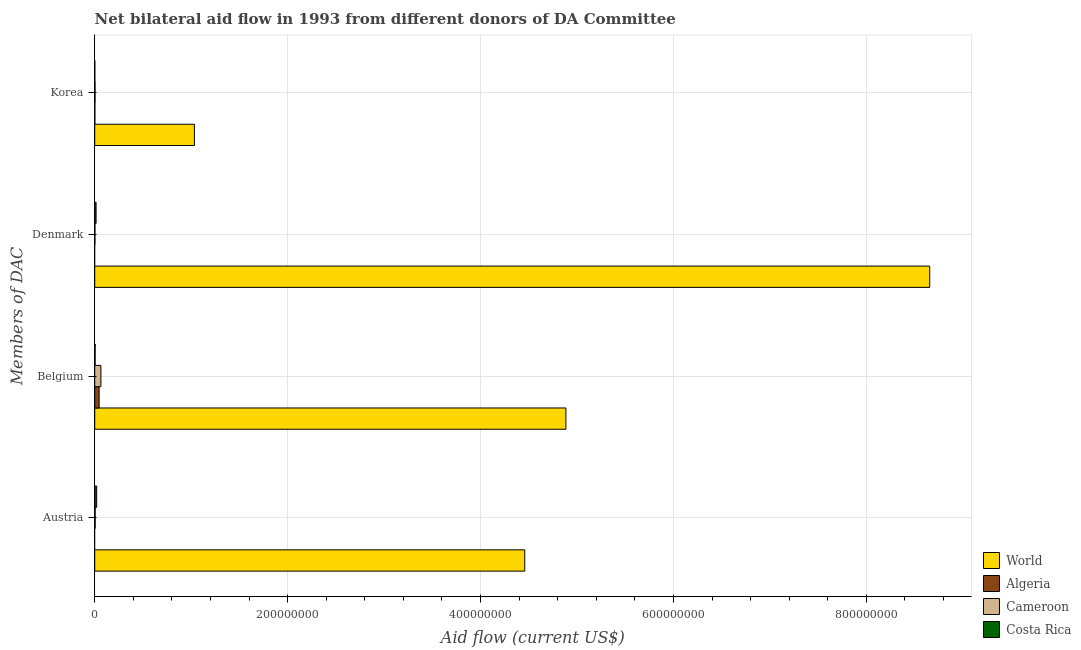How many different coloured bars are there?
Your response must be concise. 4. How many groups of bars are there?
Your answer should be compact. 4. Are the number of bars on each tick of the Y-axis equal?
Make the answer very short. No. How many bars are there on the 3rd tick from the top?
Your answer should be compact. 4. What is the label of the 3rd group of bars from the top?
Your response must be concise. Belgium. What is the amount of aid given by korea in Algeria?
Offer a very short reply. 1.10e+05. Across all countries, what is the maximum amount of aid given by korea?
Make the answer very short. 1.03e+08. In which country was the amount of aid given by austria maximum?
Make the answer very short. World. What is the total amount of aid given by denmark in the graph?
Offer a terse response. 8.67e+08. What is the difference between the amount of aid given by belgium in Algeria and that in Cameroon?
Ensure brevity in your answer.  -1.84e+06. What is the difference between the amount of aid given by belgium in Costa Rica and the amount of aid given by denmark in World?
Your answer should be very brief. -8.65e+08. What is the average amount of aid given by korea per country?
Your answer should be very brief. 2.60e+07. What is the difference between the amount of aid given by korea and amount of aid given by austria in World?
Your answer should be very brief. -3.43e+08. What is the ratio of the amount of aid given by belgium in Cameroon to that in Algeria?
Your answer should be compact. 1.4. Is the difference between the amount of aid given by austria in Cameroon and Costa Rica greater than the difference between the amount of aid given by denmark in Cameroon and Costa Rica?
Provide a succinct answer. No. What is the difference between the highest and the second highest amount of aid given by austria?
Ensure brevity in your answer.  4.44e+08. What is the difference between the highest and the lowest amount of aid given by belgium?
Your answer should be very brief. 4.88e+08. Is the sum of the amount of aid given by austria in Cameroon and World greater than the maximum amount of aid given by korea across all countries?
Offer a very short reply. Yes. Is it the case that in every country, the sum of the amount of aid given by austria and amount of aid given by belgium is greater than the amount of aid given by denmark?
Keep it short and to the point. Yes. How many bars are there?
Your response must be concise. 14. Are all the bars in the graph horizontal?
Keep it short and to the point. Yes. How many countries are there in the graph?
Offer a very short reply. 4. Does the graph contain any zero values?
Provide a short and direct response. Yes. Does the graph contain grids?
Your answer should be compact. Yes. Where does the legend appear in the graph?
Provide a succinct answer. Bottom right. How many legend labels are there?
Your response must be concise. 4. What is the title of the graph?
Your answer should be very brief. Net bilateral aid flow in 1993 from different donors of DA Committee. Does "Kyrgyz Republic" appear as one of the legend labels in the graph?
Your response must be concise. No. What is the label or title of the X-axis?
Your answer should be very brief. Aid flow (current US$). What is the label or title of the Y-axis?
Your answer should be very brief. Members of DAC. What is the Aid flow (current US$) of World in Austria?
Offer a terse response. 4.46e+08. What is the Aid flow (current US$) of Cameroon in Austria?
Your answer should be compact. 4.60e+05. What is the Aid flow (current US$) of Costa Rica in Austria?
Offer a very short reply. 2.01e+06. What is the Aid flow (current US$) of World in Belgium?
Give a very brief answer. 4.88e+08. What is the Aid flow (current US$) in Algeria in Belgium?
Ensure brevity in your answer.  4.55e+06. What is the Aid flow (current US$) in Cameroon in Belgium?
Give a very brief answer. 6.39e+06. What is the Aid flow (current US$) of World in Denmark?
Give a very brief answer. 8.66e+08. What is the Aid flow (current US$) of Algeria in Denmark?
Offer a very short reply. 0. What is the Aid flow (current US$) in Costa Rica in Denmark?
Provide a short and direct response. 1.40e+06. What is the Aid flow (current US$) in World in Korea?
Make the answer very short. 1.03e+08. What is the Aid flow (current US$) of Algeria in Korea?
Make the answer very short. 1.10e+05. What is the Aid flow (current US$) of Cameroon in Korea?
Offer a terse response. 3.30e+05. What is the Aid flow (current US$) in Costa Rica in Korea?
Your response must be concise. 1.00e+05. Across all Members of DAC, what is the maximum Aid flow (current US$) of World?
Give a very brief answer. 8.66e+08. Across all Members of DAC, what is the maximum Aid flow (current US$) of Algeria?
Your answer should be compact. 4.55e+06. Across all Members of DAC, what is the maximum Aid flow (current US$) in Cameroon?
Keep it short and to the point. 6.39e+06. Across all Members of DAC, what is the maximum Aid flow (current US$) in Costa Rica?
Offer a very short reply. 2.01e+06. Across all Members of DAC, what is the minimum Aid flow (current US$) of World?
Give a very brief answer. 1.03e+08. Across all Members of DAC, what is the minimum Aid flow (current US$) of Cameroon?
Your answer should be very brief. 2.20e+05. What is the total Aid flow (current US$) of World in the graph?
Make the answer very short. 1.90e+09. What is the total Aid flow (current US$) of Algeria in the graph?
Offer a terse response. 4.66e+06. What is the total Aid flow (current US$) of Cameroon in the graph?
Offer a very short reply. 7.40e+06. What is the total Aid flow (current US$) in Costa Rica in the graph?
Provide a short and direct response. 3.91e+06. What is the difference between the Aid flow (current US$) of World in Austria and that in Belgium?
Provide a short and direct response. -4.26e+07. What is the difference between the Aid flow (current US$) in Cameroon in Austria and that in Belgium?
Your response must be concise. -5.93e+06. What is the difference between the Aid flow (current US$) of Costa Rica in Austria and that in Belgium?
Offer a terse response. 1.61e+06. What is the difference between the Aid flow (current US$) of World in Austria and that in Denmark?
Your answer should be very brief. -4.20e+08. What is the difference between the Aid flow (current US$) of Costa Rica in Austria and that in Denmark?
Provide a short and direct response. 6.10e+05. What is the difference between the Aid flow (current US$) of World in Austria and that in Korea?
Provide a short and direct response. 3.43e+08. What is the difference between the Aid flow (current US$) of Costa Rica in Austria and that in Korea?
Your answer should be very brief. 1.91e+06. What is the difference between the Aid flow (current US$) of World in Belgium and that in Denmark?
Your response must be concise. -3.77e+08. What is the difference between the Aid flow (current US$) in Cameroon in Belgium and that in Denmark?
Make the answer very short. 6.17e+06. What is the difference between the Aid flow (current US$) of Costa Rica in Belgium and that in Denmark?
Your answer should be very brief. -1.00e+06. What is the difference between the Aid flow (current US$) in World in Belgium and that in Korea?
Give a very brief answer. 3.85e+08. What is the difference between the Aid flow (current US$) in Algeria in Belgium and that in Korea?
Your answer should be very brief. 4.44e+06. What is the difference between the Aid flow (current US$) of Cameroon in Belgium and that in Korea?
Keep it short and to the point. 6.06e+06. What is the difference between the Aid flow (current US$) of World in Denmark and that in Korea?
Your response must be concise. 7.62e+08. What is the difference between the Aid flow (current US$) of Cameroon in Denmark and that in Korea?
Offer a terse response. -1.10e+05. What is the difference between the Aid flow (current US$) in Costa Rica in Denmark and that in Korea?
Offer a very short reply. 1.30e+06. What is the difference between the Aid flow (current US$) in World in Austria and the Aid flow (current US$) in Algeria in Belgium?
Your response must be concise. 4.41e+08. What is the difference between the Aid flow (current US$) of World in Austria and the Aid flow (current US$) of Cameroon in Belgium?
Provide a short and direct response. 4.39e+08. What is the difference between the Aid flow (current US$) in World in Austria and the Aid flow (current US$) in Costa Rica in Belgium?
Your answer should be compact. 4.45e+08. What is the difference between the Aid flow (current US$) of Cameroon in Austria and the Aid flow (current US$) of Costa Rica in Belgium?
Offer a very short reply. 6.00e+04. What is the difference between the Aid flow (current US$) in World in Austria and the Aid flow (current US$) in Cameroon in Denmark?
Provide a succinct answer. 4.46e+08. What is the difference between the Aid flow (current US$) of World in Austria and the Aid flow (current US$) of Costa Rica in Denmark?
Your answer should be very brief. 4.44e+08. What is the difference between the Aid flow (current US$) of Cameroon in Austria and the Aid flow (current US$) of Costa Rica in Denmark?
Your answer should be compact. -9.40e+05. What is the difference between the Aid flow (current US$) in World in Austria and the Aid flow (current US$) in Algeria in Korea?
Offer a very short reply. 4.46e+08. What is the difference between the Aid flow (current US$) in World in Austria and the Aid flow (current US$) in Cameroon in Korea?
Provide a short and direct response. 4.46e+08. What is the difference between the Aid flow (current US$) of World in Austria and the Aid flow (current US$) of Costa Rica in Korea?
Provide a succinct answer. 4.46e+08. What is the difference between the Aid flow (current US$) in World in Belgium and the Aid flow (current US$) in Cameroon in Denmark?
Your answer should be compact. 4.88e+08. What is the difference between the Aid flow (current US$) in World in Belgium and the Aid flow (current US$) in Costa Rica in Denmark?
Provide a succinct answer. 4.87e+08. What is the difference between the Aid flow (current US$) in Algeria in Belgium and the Aid flow (current US$) in Cameroon in Denmark?
Ensure brevity in your answer.  4.33e+06. What is the difference between the Aid flow (current US$) in Algeria in Belgium and the Aid flow (current US$) in Costa Rica in Denmark?
Your response must be concise. 3.15e+06. What is the difference between the Aid flow (current US$) in Cameroon in Belgium and the Aid flow (current US$) in Costa Rica in Denmark?
Ensure brevity in your answer.  4.99e+06. What is the difference between the Aid flow (current US$) in World in Belgium and the Aid flow (current US$) in Algeria in Korea?
Keep it short and to the point. 4.88e+08. What is the difference between the Aid flow (current US$) of World in Belgium and the Aid flow (current US$) of Cameroon in Korea?
Your answer should be compact. 4.88e+08. What is the difference between the Aid flow (current US$) in World in Belgium and the Aid flow (current US$) in Costa Rica in Korea?
Your response must be concise. 4.88e+08. What is the difference between the Aid flow (current US$) of Algeria in Belgium and the Aid flow (current US$) of Cameroon in Korea?
Ensure brevity in your answer.  4.22e+06. What is the difference between the Aid flow (current US$) of Algeria in Belgium and the Aid flow (current US$) of Costa Rica in Korea?
Your response must be concise. 4.45e+06. What is the difference between the Aid flow (current US$) in Cameroon in Belgium and the Aid flow (current US$) in Costa Rica in Korea?
Keep it short and to the point. 6.29e+06. What is the difference between the Aid flow (current US$) in World in Denmark and the Aid flow (current US$) in Algeria in Korea?
Ensure brevity in your answer.  8.66e+08. What is the difference between the Aid flow (current US$) in World in Denmark and the Aid flow (current US$) in Cameroon in Korea?
Keep it short and to the point. 8.65e+08. What is the difference between the Aid flow (current US$) of World in Denmark and the Aid flow (current US$) of Costa Rica in Korea?
Keep it short and to the point. 8.66e+08. What is the average Aid flow (current US$) in World per Members of DAC?
Your response must be concise. 4.76e+08. What is the average Aid flow (current US$) of Algeria per Members of DAC?
Provide a succinct answer. 1.16e+06. What is the average Aid flow (current US$) in Cameroon per Members of DAC?
Offer a terse response. 1.85e+06. What is the average Aid flow (current US$) of Costa Rica per Members of DAC?
Provide a succinct answer. 9.78e+05. What is the difference between the Aid flow (current US$) in World and Aid flow (current US$) in Cameroon in Austria?
Your answer should be very brief. 4.45e+08. What is the difference between the Aid flow (current US$) in World and Aid flow (current US$) in Costa Rica in Austria?
Your answer should be compact. 4.44e+08. What is the difference between the Aid flow (current US$) of Cameroon and Aid flow (current US$) of Costa Rica in Austria?
Your answer should be very brief. -1.55e+06. What is the difference between the Aid flow (current US$) in World and Aid flow (current US$) in Algeria in Belgium?
Ensure brevity in your answer.  4.84e+08. What is the difference between the Aid flow (current US$) in World and Aid flow (current US$) in Cameroon in Belgium?
Your answer should be very brief. 4.82e+08. What is the difference between the Aid flow (current US$) of World and Aid flow (current US$) of Costa Rica in Belgium?
Keep it short and to the point. 4.88e+08. What is the difference between the Aid flow (current US$) of Algeria and Aid flow (current US$) of Cameroon in Belgium?
Provide a short and direct response. -1.84e+06. What is the difference between the Aid flow (current US$) of Algeria and Aid flow (current US$) of Costa Rica in Belgium?
Your answer should be compact. 4.15e+06. What is the difference between the Aid flow (current US$) of Cameroon and Aid flow (current US$) of Costa Rica in Belgium?
Give a very brief answer. 5.99e+06. What is the difference between the Aid flow (current US$) of World and Aid flow (current US$) of Cameroon in Denmark?
Provide a short and direct response. 8.65e+08. What is the difference between the Aid flow (current US$) of World and Aid flow (current US$) of Costa Rica in Denmark?
Your answer should be very brief. 8.64e+08. What is the difference between the Aid flow (current US$) of Cameroon and Aid flow (current US$) of Costa Rica in Denmark?
Your answer should be compact. -1.18e+06. What is the difference between the Aid flow (current US$) of World and Aid flow (current US$) of Algeria in Korea?
Your answer should be very brief. 1.03e+08. What is the difference between the Aid flow (current US$) in World and Aid flow (current US$) in Cameroon in Korea?
Provide a short and direct response. 1.03e+08. What is the difference between the Aid flow (current US$) of World and Aid flow (current US$) of Costa Rica in Korea?
Offer a terse response. 1.03e+08. What is the difference between the Aid flow (current US$) of Algeria and Aid flow (current US$) of Cameroon in Korea?
Ensure brevity in your answer.  -2.20e+05. What is the difference between the Aid flow (current US$) of Cameroon and Aid flow (current US$) of Costa Rica in Korea?
Your answer should be compact. 2.30e+05. What is the ratio of the Aid flow (current US$) in World in Austria to that in Belgium?
Offer a terse response. 0.91. What is the ratio of the Aid flow (current US$) of Cameroon in Austria to that in Belgium?
Make the answer very short. 0.07. What is the ratio of the Aid flow (current US$) in Costa Rica in Austria to that in Belgium?
Offer a terse response. 5.03. What is the ratio of the Aid flow (current US$) in World in Austria to that in Denmark?
Offer a terse response. 0.52. What is the ratio of the Aid flow (current US$) of Cameroon in Austria to that in Denmark?
Offer a very short reply. 2.09. What is the ratio of the Aid flow (current US$) of Costa Rica in Austria to that in Denmark?
Your answer should be very brief. 1.44. What is the ratio of the Aid flow (current US$) of World in Austria to that in Korea?
Ensure brevity in your answer.  4.31. What is the ratio of the Aid flow (current US$) in Cameroon in Austria to that in Korea?
Make the answer very short. 1.39. What is the ratio of the Aid flow (current US$) of Costa Rica in Austria to that in Korea?
Provide a short and direct response. 20.1. What is the ratio of the Aid flow (current US$) of World in Belgium to that in Denmark?
Your answer should be very brief. 0.56. What is the ratio of the Aid flow (current US$) of Cameroon in Belgium to that in Denmark?
Your answer should be compact. 29.05. What is the ratio of the Aid flow (current US$) in Costa Rica in Belgium to that in Denmark?
Keep it short and to the point. 0.29. What is the ratio of the Aid flow (current US$) of World in Belgium to that in Korea?
Provide a succinct answer. 4.73. What is the ratio of the Aid flow (current US$) in Algeria in Belgium to that in Korea?
Provide a short and direct response. 41.36. What is the ratio of the Aid flow (current US$) in Cameroon in Belgium to that in Korea?
Provide a short and direct response. 19.36. What is the ratio of the Aid flow (current US$) of Costa Rica in Belgium to that in Korea?
Your response must be concise. 4. What is the ratio of the Aid flow (current US$) of World in Denmark to that in Korea?
Your answer should be compact. 8.38. What is the ratio of the Aid flow (current US$) of Cameroon in Denmark to that in Korea?
Provide a succinct answer. 0.67. What is the difference between the highest and the second highest Aid flow (current US$) in World?
Make the answer very short. 3.77e+08. What is the difference between the highest and the second highest Aid flow (current US$) of Cameroon?
Keep it short and to the point. 5.93e+06. What is the difference between the highest and the second highest Aid flow (current US$) of Costa Rica?
Your response must be concise. 6.10e+05. What is the difference between the highest and the lowest Aid flow (current US$) in World?
Your answer should be very brief. 7.62e+08. What is the difference between the highest and the lowest Aid flow (current US$) in Algeria?
Your response must be concise. 4.55e+06. What is the difference between the highest and the lowest Aid flow (current US$) of Cameroon?
Give a very brief answer. 6.17e+06. What is the difference between the highest and the lowest Aid flow (current US$) of Costa Rica?
Offer a terse response. 1.91e+06. 